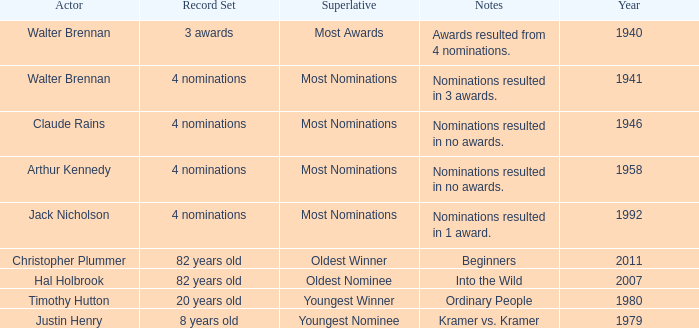What record was set by walter brennan before 1941? 3 awards. 